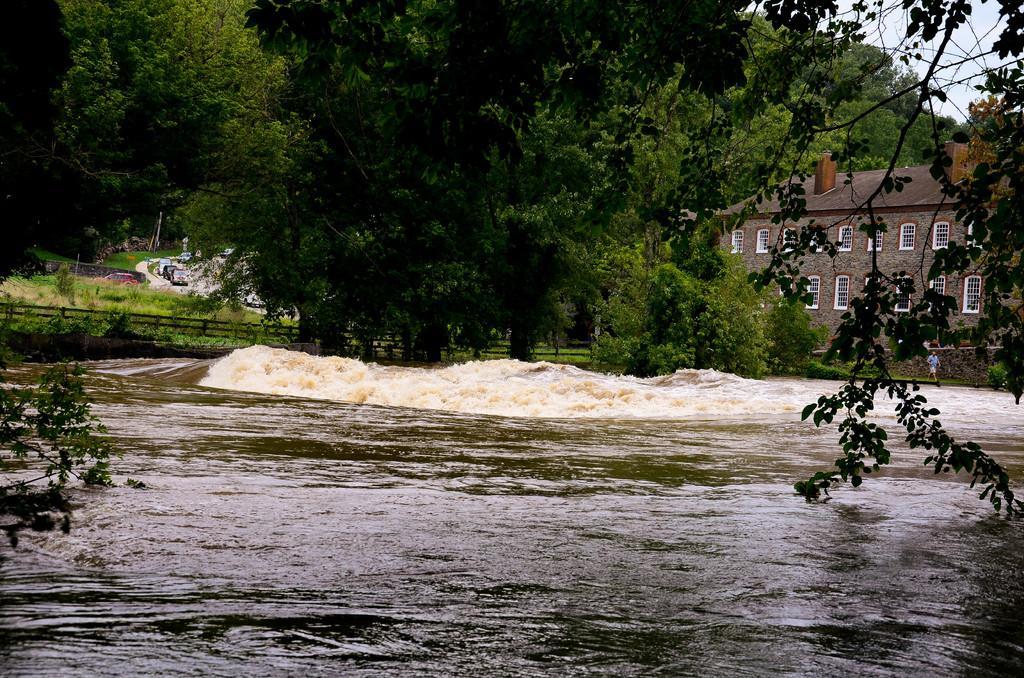Can you describe this image briefly? In this image there is a canal , at the top there is a building, the sky, trees visible, in front of the building there is a person in the middle, both side of the image there are tree branches visible. 